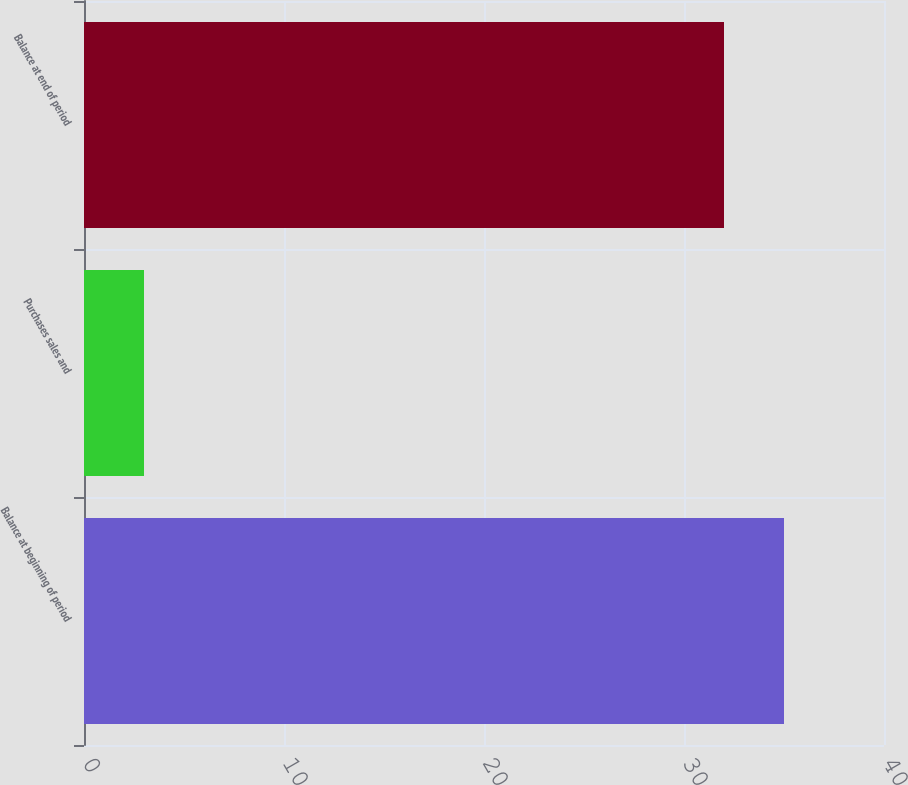Convert chart to OTSL. <chart><loc_0><loc_0><loc_500><loc_500><bar_chart><fcel>Balance at beginning of period<fcel>Purchases sales and<fcel>Balance at end of period<nl><fcel>35<fcel>3<fcel>32<nl></chart> 